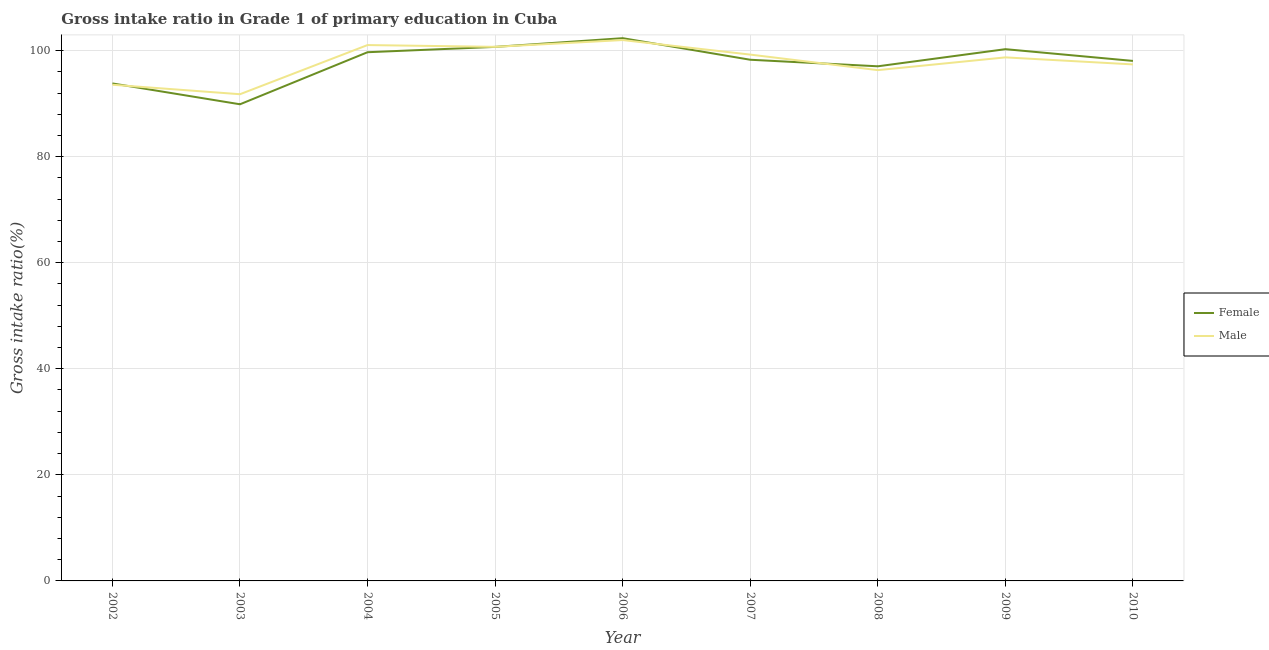What is the gross intake ratio(female) in 2009?
Offer a very short reply. 100.26. Across all years, what is the maximum gross intake ratio(male)?
Keep it short and to the point. 101.98. Across all years, what is the minimum gross intake ratio(male)?
Make the answer very short. 91.77. In which year was the gross intake ratio(male) maximum?
Offer a terse response. 2006. What is the total gross intake ratio(female) in the graph?
Make the answer very short. 880.02. What is the difference between the gross intake ratio(male) in 2002 and that in 2008?
Give a very brief answer. -2.76. What is the difference between the gross intake ratio(female) in 2006 and the gross intake ratio(male) in 2007?
Your answer should be compact. 3.1. What is the average gross intake ratio(male) per year?
Your answer should be compact. 97.86. In the year 2010, what is the difference between the gross intake ratio(female) and gross intake ratio(male)?
Ensure brevity in your answer.  0.66. What is the ratio of the gross intake ratio(female) in 2005 to that in 2010?
Keep it short and to the point. 1.03. Is the gross intake ratio(male) in 2002 less than that in 2010?
Make the answer very short. Yes. What is the difference between the highest and the second highest gross intake ratio(male)?
Keep it short and to the point. 0.94. What is the difference between the highest and the lowest gross intake ratio(female)?
Your response must be concise. 12.46. In how many years, is the gross intake ratio(female) greater than the average gross intake ratio(female) taken over all years?
Your answer should be compact. 6. Is the sum of the gross intake ratio(male) in 2005 and 2007 greater than the maximum gross intake ratio(female) across all years?
Provide a succinct answer. Yes. What is the difference between two consecutive major ticks on the Y-axis?
Ensure brevity in your answer.  20. What is the title of the graph?
Make the answer very short. Gross intake ratio in Grade 1 of primary education in Cuba. Does "Male labor force" appear as one of the legend labels in the graph?
Make the answer very short. No. What is the label or title of the X-axis?
Make the answer very short. Year. What is the label or title of the Y-axis?
Ensure brevity in your answer.  Gross intake ratio(%). What is the Gross intake ratio(%) in Female in 2002?
Your response must be concise. 93.8. What is the Gross intake ratio(%) in Male in 2002?
Offer a terse response. 93.56. What is the Gross intake ratio(%) in Female in 2003?
Provide a short and direct response. 89.87. What is the Gross intake ratio(%) of Male in 2003?
Your answer should be very brief. 91.77. What is the Gross intake ratio(%) in Female in 2004?
Offer a terse response. 99.69. What is the Gross intake ratio(%) of Male in 2004?
Make the answer very short. 101.04. What is the Gross intake ratio(%) of Female in 2005?
Make the answer very short. 100.69. What is the Gross intake ratio(%) of Male in 2005?
Keep it short and to the point. 100.7. What is the Gross intake ratio(%) in Female in 2006?
Your answer should be very brief. 102.34. What is the Gross intake ratio(%) in Male in 2006?
Keep it short and to the point. 101.98. What is the Gross intake ratio(%) in Female in 2007?
Give a very brief answer. 98.27. What is the Gross intake ratio(%) of Male in 2007?
Provide a succinct answer. 99.24. What is the Gross intake ratio(%) in Female in 2008?
Offer a very short reply. 97.04. What is the Gross intake ratio(%) in Male in 2008?
Keep it short and to the point. 96.31. What is the Gross intake ratio(%) in Female in 2009?
Give a very brief answer. 100.26. What is the Gross intake ratio(%) of Male in 2009?
Offer a very short reply. 98.72. What is the Gross intake ratio(%) of Female in 2010?
Your answer should be very brief. 98.05. What is the Gross intake ratio(%) in Male in 2010?
Make the answer very short. 97.39. Across all years, what is the maximum Gross intake ratio(%) of Female?
Give a very brief answer. 102.34. Across all years, what is the maximum Gross intake ratio(%) in Male?
Your answer should be compact. 101.98. Across all years, what is the minimum Gross intake ratio(%) in Female?
Offer a very short reply. 89.87. Across all years, what is the minimum Gross intake ratio(%) of Male?
Keep it short and to the point. 91.77. What is the total Gross intake ratio(%) of Female in the graph?
Keep it short and to the point. 880.02. What is the total Gross intake ratio(%) of Male in the graph?
Provide a succinct answer. 880.72. What is the difference between the Gross intake ratio(%) in Female in 2002 and that in 2003?
Ensure brevity in your answer.  3.93. What is the difference between the Gross intake ratio(%) of Male in 2002 and that in 2003?
Your answer should be compact. 1.79. What is the difference between the Gross intake ratio(%) in Female in 2002 and that in 2004?
Keep it short and to the point. -5.89. What is the difference between the Gross intake ratio(%) in Male in 2002 and that in 2004?
Offer a terse response. -7.48. What is the difference between the Gross intake ratio(%) of Female in 2002 and that in 2005?
Provide a succinct answer. -6.89. What is the difference between the Gross intake ratio(%) in Male in 2002 and that in 2005?
Your answer should be compact. -7.15. What is the difference between the Gross intake ratio(%) in Female in 2002 and that in 2006?
Make the answer very short. -8.53. What is the difference between the Gross intake ratio(%) of Male in 2002 and that in 2006?
Ensure brevity in your answer.  -8.43. What is the difference between the Gross intake ratio(%) of Female in 2002 and that in 2007?
Offer a terse response. -4.47. What is the difference between the Gross intake ratio(%) of Male in 2002 and that in 2007?
Provide a succinct answer. -5.68. What is the difference between the Gross intake ratio(%) of Female in 2002 and that in 2008?
Ensure brevity in your answer.  -3.23. What is the difference between the Gross intake ratio(%) of Male in 2002 and that in 2008?
Give a very brief answer. -2.76. What is the difference between the Gross intake ratio(%) of Female in 2002 and that in 2009?
Ensure brevity in your answer.  -6.46. What is the difference between the Gross intake ratio(%) of Male in 2002 and that in 2009?
Offer a terse response. -5.16. What is the difference between the Gross intake ratio(%) in Female in 2002 and that in 2010?
Ensure brevity in your answer.  -4.25. What is the difference between the Gross intake ratio(%) in Male in 2002 and that in 2010?
Keep it short and to the point. -3.83. What is the difference between the Gross intake ratio(%) in Female in 2003 and that in 2004?
Give a very brief answer. -9.82. What is the difference between the Gross intake ratio(%) in Male in 2003 and that in 2004?
Your response must be concise. -9.27. What is the difference between the Gross intake ratio(%) of Female in 2003 and that in 2005?
Offer a terse response. -10.82. What is the difference between the Gross intake ratio(%) in Male in 2003 and that in 2005?
Offer a terse response. -8.93. What is the difference between the Gross intake ratio(%) of Female in 2003 and that in 2006?
Your answer should be very brief. -12.46. What is the difference between the Gross intake ratio(%) in Male in 2003 and that in 2006?
Keep it short and to the point. -10.21. What is the difference between the Gross intake ratio(%) of Female in 2003 and that in 2007?
Offer a very short reply. -8.4. What is the difference between the Gross intake ratio(%) in Male in 2003 and that in 2007?
Your answer should be compact. -7.47. What is the difference between the Gross intake ratio(%) of Female in 2003 and that in 2008?
Give a very brief answer. -7.16. What is the difference between the Gross intake ratio(%) of Male in 2003 and that in 2008?
Offer a very short reply. -4.54. What is the difference between the Gross intake ratio(%) in Female in 2003 and that in 2009?
Keep it short and to the point. -10.39. What is the difference between the Gross intake ratio(%) of Male in 2003 and that in 2009?
Provide a short and direct response. -6.95. What is the difference between the Gross intake ratio(%) in Female in 2003 and that in 2010?
Your response must be concise. -8.18. What is the difference between the Gross intake ratio(%) in Male in 2003 and that in 2010?
Keep it short and to the point. -5.62. What is the difference between the Gross intake ratio(%) of Female in 2004 and that in 2005?
Ensure brevity in your answer.  -1. What is the difference between the Gross intake ratio(%) in Male in 2004 and that in 2005?
Your response must be concise. 0.34. What is the difference between the Gross intake ratio(%) in Female in 2004 and that in 2006?
Your answer should be very brief. -2.65. What is the difference between the Gross intake ratio(%) in Male in 2004 and that in 2006?
Your answer should be compact. -0.94. What is the difference between the Gross intake ratio(%) of Female in 2004 and that in 2007?
Your answer should be compact. 1.42. What is the difference between the Gross intake ratio(%) of Male in 2004 and that in 2007?
Provide a short and direct response. 1.8. What is the difference between the Gross intake ratio(%) in Female in 2004 and that in 2008?
Provide a short and direct response. 2.65. What is the difference between the Gross intake ratio(%) in Male in 2004 and that in 2008?
Ensure brevity in your answer.  4.73. What is the difference between the Gross intake ratio(%) of Female in 2004 and that in 2009?
Provide a succinct answer. -0.57. What is the difference between the Gross intake ratio(%) in Male in 2004 and that in 2009?
Keep it short and to the point. 2.32. What is the difference between the Gross intake ratio(%) of Female in 2004 and that in 2010?
Your answer should be very brief. 1.64. What is the difference between the Gross intake ratio(%) of Male in 2004 and that in 2010?
Offer a very short reply. 3.65. What is the difference between the Gross intake ratio(%) in Female in 2005 and that in 2006?
Keep it short and to the point. -1.64. What is the difference between the Gross intake ratio(%) in Male in 2005 and that in 2006?
Make the answer very short. -1.28. What is the difference between the Gross intake ratio(%) in Female in 2005 and that in 2007?
Offer a terse response. 2.42. What is the difference between the Gross intake ratio(%) of Male in 2005 and that in 2007?
Give a very brief answer. 1.46. What is the difference between the Gross intake ratio(%) of Female in 2005 and that in 2008?
Offer a terse response. 3.66. What is the difference between the Gross intake ratio(%) in Male in 2005 and that in 2008?
Give a very brief answer. 4.39. What is the difference between the Gross intake ratio(%) in Female in 2005 and that in 2009?
Give a very brief answer. 0.43. What is the difference between the Gross intake ratio(%) in Male in 2005 and that in 2009?
Provide a succinct answer. 1.99. What is the difference between the Gross intake ratio(%) of Female in 2005 and that in 2010?
Your answer should be very brief. 2.64. What is the difference between the Gross intake ratio(%) in Male in 2005 and that in 2010?
Ensure brevity in your answer.  3.31. What is the difference between the Gross intake ratio(%) in Female in 2006 and that in 2007?
Your answer should be very brief. 4.07. What is the difference between the Gross intake ratio(%) of Male in 2006 and that in 2007?
Offer a very short reply. 2.74. What is the difference between the Gross intake ratio(%) in Female in 2006 and that in 2008?
Provide a short and direct response. 5.3. What is the difference between the Gross intake ratio(%) in Male in 2006 and that in 2008?
Provide a succinct answer. 5.67. What is the difference between the Gross intake ratio(%) in Female in 2006 and that in 2009?
Your response must be concise. 2.07. What is the difference between the Gross intake ratio(%) in Male in 2006 and that in 2009?
Your response must be concise. 3.27. What is the difference between the Gross intake ratio(%) of Female in 2006 and that in 2010?
Provide a succinct answer. 4.29. What is the difference between the Gross intake ratio(%) of Male in 2006 and that in 2010?
Your answer should be very brief. 4.59. What is the difference between the Gross intake ratio(%) of Female in 2007 and that in 2008?
Provide a succinct answer. 1.23. What is the difference between the Gross intake ratio(%) of Male in 2007 and that in 2008?
Make the answer very short. 2.93. What is the difference between the Gross intake ratio(%) in Female in 2007 and that in 2009?
Give a very brief answer. -1.99. What is the difference between the Gross intake ratio(%) in Male in 2007 and that in 2009?
Your answer should be very brief. 0.52. What is the difference between the Gross intake ratio(%) of Female in 2007 and that in 2010?
Give a very brief answer. 0.22. What is the difference between the Gross intake ratio(%) of Male in 2007 and that in 2010?
Ensure brevity in your answer.  1.85. What is the difference between the Gross intake ratio(%) of Female in 2008 and that in 2009?
Your answer should be compact. -3.23. What is the difference between the Gross intake ratio(%) of Male in 2008 and that in 2009?
Your response must be concise. -2.41. What is the difference between the Gross intake ratio(%) in Female in 2008 and that in 2010?
Make the answer very short. -1.01. What is the difference between the Gross intake ratio(%) in Male in 2008 and that in 2010?
Provide a short and direct response. -1.08. What is the difference between the Gross intake ratio(%) in Female in 2009 and that in 2010?
Ensure brevity in your answer.  2.21. What is the difference between the Gross intake ratio(%) of Male in 2009 and that in 2010?
Offer a very short reply. 1.33. What is the difference between the Gross intake ratio(%) of Female in 2002 and the Gross intake ratio(%) of Male in 2003?
Give a very brief answer. 2.03. What is the difference between the Gross intake ratio(%) of Female in 2002 and the Gross intake ratio(%) of Male in 2004?
Your response must be concise. -7.24. What is the difference between the Gross intake ratio(%) in Female in 2002 and the Gross intake ratio(%) in Male in 2005?
Provide a succinct answer. -6.9. What is the difference between the Gross intake ratio(%) in Female in 2002 and the Gross intake ratio(%) in Male in 2006?
Your answer should be very brief. -8.18. What is the difference between the Gross intake ratio(%) of Female in 2002 and the Gross intake ratio(%) of Male in 2007?
Ensure brevity in your answer.  -5.44. What is the difference between the Gross intake ratio(%) in Female in 2002 and the Gross intake ratio(%) in Male in 2008?
Your answer should be compact. -2.51. What is the difference between the Gross intake ratio(%) in Female in 2002 and the Gross intake ratio(%) in Male in 2009?
Keep it short and to the point. -4.91. What is the difference between the Gross intake ratio(%) of Female in 2002 and the Gross intake ratio(%) of Male in 2010?
Offer a terse response. -3.59. What is the difference between the Gross intake ratio(%) of Female in 2003 and the Gross intake ratio(%) of Male in 2004?
Your answer should be very brief. -11.17. What is the difference between the Gross intake ratio(%) in Female in 2003 and the Gross intake ratio(%) in Male in 2005?
Provide a succinct answer. -10.83. What is the difference between the Gross intake ratio(%) of Female in 2003 and the Gross intake ratio(%) of Male in 2006?
Offer a very short reply. -12.11. What is the difference between the Gross intake ratio(%) of Female in 2003 and the Gross intake ratio(%) of Male in 2007?
Make the answer very short. -9.37. What is the difference between the Gross intake ratio(%) of Female in 2003 and the Gross intake ratio(%) of Male in 2008?
Your answer should be compact. -6.44. What is the difference between the Gross intake ratio(%) of Female in 2003 and the Gross intake ratio(%) of Male in 2009?
Keep it short and to the point. -8.84. What is the difference between the Gross intake ratio(%) in Female in 2003 and the Gross intake ratio(%) in Male in 2010?
Your answer should be compact. -7.52. What is the difference between the Gross intake ratio(%) in Female in 2004 and the Gross intake ratio(%) in Male in 2005?
Give a very brief answer. -1.01. What is the difference between the Gross intake ratio(%) in Female in 2004 and the Gross intake ratio(%) in Male in 2006?
Provide a short and direct response. -2.29. What is the difference between the Gross intake ratio(%) in Female in 2004 and the Gross intake ratio(%) in Male in 2007?
Ensure brevity in your answer.  0.45. What is the difference between the Gross intake ratio(%) in Female in 2004 and the Gross intake ratio(%) in Male in 2008?
Ensure brevity in your answer.  3.38. What is the difference between the Gross intake ratio(%) of Female in 2004 and the Gross intake ratio(%) of Male in 2009?
Ensure brevity in your answer.  0.97. What is the difference between the Gross intake ratio(%) in Female in 2004 and the Gross intake ratio(%) in Male in 2010?
Make the answer very short. 2.3. What is the difference between the Gross intake ratio(%) in Female in 2005 and the Gross intake ratio(%) in Male in 2006?
Provide a succinct answer. -1.29. What is the difference between the Gross intake ratio(%) in Female in 2005 and the Gross intake ratio(%) in Male in 2007?
Provide a succinct answer. 1.45. What is the difference between the Gross intake ratio(%) of Female in 2005 and the Gross intake ratio(%) of Male in 2008?
Make the answer very short. 4.38. What is the difference between the Gross intake ratio(%) of Female in 2005 and the Gross intake ratio(%) of Male in 2009?
Your answer should be compact. 1.98. What is the difference between the Gross intake ratio(%) in Female in 2005 and the Gross intake ratio(%) in Male in 2010?
Your answer should be very brief. 3.3. What is the difference between the Gross intake ratio(%) of Female in 2006 and the Gross intake ratio(%) of Male in 2007?
Give a very brief answer. 3.1. What is the difference between the Gross intake ratio(%) in Female in 2006 and the Gross intake ratio(%) in Male in 2008?
Offer a very short reply. 6.02. What is the difference between the Gross intake ratio(%) in Female in 2006 and the Gross intake ratio(%) in Male in 2009?
Provide a succinct answer. 3.62. What is the difference between the Gross intake ratio(%) of Female in 2006 and the Gross intake ratio(%) of Male in 2010?
Your answer should be very brief. 4.95. What is the difference between the Gross intake ratio(%) of Female in 2007 and the Gross intake ratio(%) of Male in 2008?
Give a very brief answer. 1.96. What is the difference between the Gross intake ratio(%) in Female in 2007 and the Gross intake ratio(%) in Male in 2009?
Your answer should be very brief. -0.45. What is the difference between the Gross intake ratio(%) of Female in 2007 and the Gross intake ratio(%) of Male in 2010?
Provide a succinct answer. 0.88. What is the difference between the Gross intake ratio(%) in Female in 2008 and the Gross intake ratio(%) in Male in 2009?
Make the answer very short. -1.68. What is the difference between the Gross intake ratio(%) in Female in 2008 and the Gross intake ratio(%) in Male in 2010?
Provide a short and direct response. -0.36. What is the difference between the Gross intake ratio(%) of Female in 2009 and the Gross intake ratio(%) of Male in 2010?
Provide a succinct answer. 2.87. What is the average Gross intake ratio(%) of Female per year?
Your response must be concise. 97.78. What is the average Gross intake ratio(%) in Male per year?
Make the answer very short. 97.86. In the year 2002, what is the difference between the Gross intake ratio(%) of Female and Gross intake ratio(%) of Male?
Make the answer very short. 0.25. In the year 2003, what is the difference between the Gross intake ratio(%) in Female and Gross intake ratio(%) in Male?
Your answer should be compact. -1.9. In the year 2004, what is the difference between the Gross intake ratio(%) of Female and Gross intake ratio(%) of Male?
Ensure brevity in your answer.  -1.35. In the year 2005, what is the difference between the Gross intake ratio(%) in Female and Gross intake ratio(%) in Male?
Offer a terse response. -0.01. In the year 2006, what is the difference between the Gross intake ratio(%) of Female and Gross intake ratio(%) of Male?
Provide a short and direct response. 0.35. In the year 2007, what is the difference between the Gross intake ratio(%) of Female and Gross intake ratio(%) of Male?
Your answer should be compact. -0.97. In the year 2008, what is the difference between the Gross intake ratio(%) of Female and Gross intake ratio(%) of Male?
Give a very brief answer. 0.72. In the year 2009, what is the difference between the Gross intake ratio(%) of Female and Gross intake ratio(%) of Male?
Your answer should be compact. 1.55. In the year 2010, what is the difference between the Gross intake ratio(%) in Female and Gross intake ratio(%) in Male?
Give a very brief answer. 0.66. What is the ratio of the Gross intake ratio(%) of Female in 2002 to that in 2003?
Offer a terse response. 1.04. What is the ratio of the Gross intake ratio(%) of Male in 2002 to that in 2003?
Provide a short and direct response. 1.02. What is the ratio of the Gross intake ratio(%) of Female in 2002 to that in 2004?
Ensure brevity in your answer.  0.94. What is the ratio of the Gross intake ratio(%) of Male in 2002 to that in 2004?
Offer a very short reply. 0.93. What is the ratio of the Gross intake ratio(%) of Female in 2002 to that in 2005?
Provide a succinct answer. 0.93. What is the ratio of the Gross intake ratio(%) of Male in 2002 to that in 2005?
Provide a short and direct response. 0.93. What is the ratio of the Gross intake ratio(%) in Female in 2002 to that in 2006?
Make the answer very short. 0.92. What is the ratio of the Gross intake ratio(%) of Male in 2002 to that in 2006?
Offer a very short reply. 0.92. What is the ratio of the Gross intake ratio(%) in Female in 2002 to that in 2007?
Your answer should be very brief. 0.95. What is the ratio of the Gross intake ratio(%) of Male in 2002 to that in 2007?
Your response must be concise. 0.94. What is the ratio of the Gross intake ratio(%) in Female in 2002 to that in 2008?
Give a very brief answer. 0.97. What is the ratio of the Gross intake ratio(%) in Male in 2002 to that in 2008?
Your response must be concise. 0.97. What is the ratio of the Gross intake ratio(%) of Female in 2002 to that in 2009?
Offer a very short reply. 0.94. What is the ratio of the Gross intake ratio(%) of Male in 2002 to that in 2009?
Your answer should be compact. 0.95. What is the ratio of the Gross intake ratio(%) of Female in 2002 to that in 2010?
Make the answer very short. 0.96. What is the ratio of the Gross intake ratio(%) of Male in 2002 to that in 2010?
Provide a short and direct response. 0.96. What is the ratio of the Gross intake ratio(%) of Female in 2003 to that in 2004?
Your answer should be very brief. 0.9. What is the ratio of the Gross intake ratio(%) in Male in 2003 to that in 2004?
Your response must be concise. 0.91. What is the ratio of the Gross intake ratio(%) of Female in 2003 to that in 2005?
Offer a very short reply. 0.89. What is the ratio of the Gross intake ratio(%) of Male in 2003 to that in 2005?
Provide a short and direct response. 0.91. What is the ratio of the Gross intake ratio(%) of Female in 2003 to that in 2006?
Provide a succinct answer. 0.88. What is the ratio of the Gross intake ratio(%) of Male in 2003 to that in 2006?
Offer a terse response. 0.9. What is the ratio of the Gross intake ratio(%) in Female in 2003 to that in 2007?
Offer a terse response. 0.91. What is the ratio of the Gross intake ratio(%) of Male in 2003 to that in 2007?
Give a very brief answer. 0.92. What is the ratio of the Gross intake ratio(%) in Female in 2003 to that in 2008?
Provide a succinct answer. 0.93. What is the ratio of the Gross intake ratio(%) of Male in 2003 to that in 2008?
Your answer should be very brief. 0.95. What is the ratio of the Gross intake ratio(%) of Female in 2003 to that in 2009?
Make the answer very short. 0.9. What is the ratio of the Gross intake ratio(%) in Male in 2003 to that in 2009?
Provide a short and direct response. 0.93. What is the ratio of the Gross intake ratio(%) in Female in 2003 to that in 2010?
Your answer should be very brief. 0.92. What is the ratio of the Gross intake ratio(%) in Male in 2003 to that in 2010?
Provide a short and direct response. 0.94. What is the ratio of the Gross intake ratio(%) in Female in 2004 to that in 2006?
Your response must be concise. 0.97. What is the ratio of the Gross intake ratio(%) in Female in 2004 to that in 2007?
Keep it short and to the point. 1.01. What is the ratio of the Gross intake ratio(%) in Male in 2004 to that in 2007?
Provide a succinct answer. 1.02. What is the ratio of the Gross intake ratio(%) of Female in 2004 to that in 2008?
Make the answer very short. 1.03. What is the ratio of the Gross intake ratio(%) in Male in 2004 to that in 2008?
Your response must be concise. 1.05. What is the ratio of the Gross intake ratio(%) of Male in 2004 to that in 2009?
Your answer should be compact. 1.02. What is the ratio of the Gross intake ratio(%) in Female in 2004 to that in 2010?
Your answer should be compact. 1.02. What is the ratio of the Gross intake ratio(%) in Male in 2004 to that in 2010?
Offer a terse response. 1.04. What is the ratio of the Gross intake ratio(%) in Female in 2005 to that in 2006?
Keep it short and to the point. 0.98. What is the ratio of the Gross intake ratio(%) of Male in 2005 to that in 2006?
Provide a succinct answer. 0.99. What is the ratio of the Gross intake ratio(%) of Female in 2005 to that in 2007?
Give a very brief answer. 1.02. What is the ratio of the Gross intake ratio(%) in Male in 2005 to that in 2007?
Keep it short and to the point. 1.01. What is the ratio of the Gross intake ratio(%) in Female in 2005 to that in 2008?
Keep it short and to the point. 1.04. What is the ratio of the Gross intake ratio(%) of Male in 2005 to that in 2008?
Provide a short and direct response. 1.05. What is the ratio of the Gross intake ratio(%) of Female in 2005 to that in 2009?
Offer a terse response. 1. What is the ratio of the Gross intake ratio(%) of Male in 2005 to that in 2009?
Offer a very short reply. 1.02. What is the ratio of the Gross intake ratio(%) in Male in 2005 to that in 2010?
Your answer should be very brief. 1.03. What is the ratio of the Gross intake ratio(%) of Female in 2006 to that in 2007?
Your answer should be compact. 1.04. What is the ratio of the Gross intake ratio(%) in Male in 2006 to that in 2007?
Your response must be concise. 1.03. What is the ratio of the Gross intake ratio(%) in Female in 2006 to that in 2008?
Offer a very short reply. 1.05. What is the ratio of the Gross intake ratio(%) in Male in 2006 to that in 2008?
Offer a terse response. 1.06. What is the ratio of the Gross intake ratio(%) in Female in 2006 to that in 2009?
Provide a short and direct response. 1.02. What is the ratio of the Gross intake ratio(%) of Male in 2006 to that in 2009?
Give a very brief answer. 1.03. What is the ratio of the Gross intake ratio(%) of Female in 2006 to that in 2010?
Give a very brief answer. 1.04. What is the ratio of the Gross intake ratio(%) of Male in 2006 to that in 2010?
Your response must be concise. 1.05. What is the ratio of the Gross intake ratio(%) of Female in 2007 to that in 2008?
Make the answer very short. 1.01. What is the ratio of the Gross intake ratio(%) in Male in 2007 to that in 2008?
Provide a succinct answer. 1.03. What is the ratio of the Gross intake ratio(%) in Female in 2007 to that in 2009?
Keep it short and to the point. 0.98. What is the ratio of the Gross intake ratio(%) of Male in 2007 to that in 2009?
Offer a terse response. 1.01. What is the ratio of the Gross intake ratio(%) in Male in 2007 to that in 2010?
Your answer should be very brief. 1.02. What is the ratio of the Gross intake ratio(%) of Female in 2008 to that in 2009?
Provide a succinct answer. 0.97. What is the ratio of the Gross intake ratio(%) in Male in 2008 to that in 2009?
Provide a succinct answer. 0.98. What is the ratio of the Gross intake ratio(%) of Female in 2008 to that in 2010?
Provide a short and direct response. 0.99. What is the ratio of the Gross intake ratio(%) in Male in 2008 to that in 2010?
Make the answer very short. 0.99. What is the ratio of the Gross intake ratio(%) in Female in 2009 to that in 2010?
Give a very brief answer. 1.02. What is the ratio of the Gross intake ratio(%) in Male in 2009 to that in 2010?
Provide a succinct answer. 1.01. What is the difference between the highest and the second highest Gross intake ratio(%) in Female?
Provide a short and direct response. 1.64. What is the difference between the highest and the second highest Gross intake ratio(%) of Male?
Offer a very short reply. 0.94. What is the difference between the highest and the lowest Gross intake ratio(%) of Female?
Offer a terse response. 12.46. What is the difference between the highest and the lowest Gross intake ratio(%) of Male?
Your answer should be compact. 10.21. 